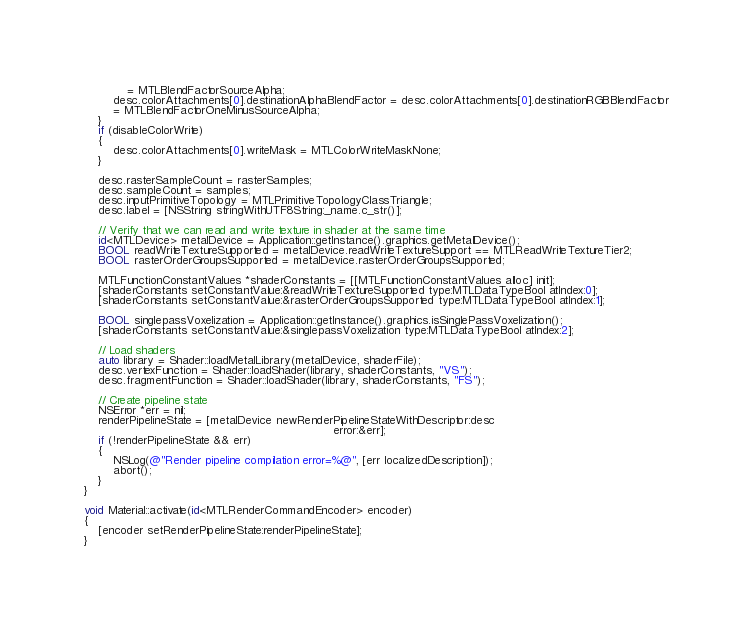Convert code to text. <code><loc_0><loc_0><loc_500><loc_500><_ObjectiveC_>			= MTLBlendFactorSourceAlpha;
		desc.colorAttachments[0].destinationAlphaBlendFactor = desc.colorAttachments[0].destinationRGBBlendFactor
		= MTLBlendFactorOneMinusSourceAlpha;
	}
	if (disableColorWrite)
	{
		desc.colorAttachments[0].writeMask = MTLColorWriteMaskNone;
	}

	desc.rasterSampleCount = rasterSamples;
	desc.sampleCount = samples;
	desc.inputPrimitiveTopology = MTLPrimitiveTopologyClassTriangle;
	desc.label = [NSString stringWithUTF8String:_name.c_str()];

	// Verify that we can read and write texture in shader at the same time
	id<MTLDevice> metalDevice = Application::getInstance().graphics.getMetalDevice();
	BOOL readWriteTextureSupported = metalDevice.readWriteTextureSupport == MTLReadWriteTextureTier2;
	BOOL rasterOrderGroupsSupported = metalDevice.rasterOrderGroupsSupported;

	MTLFunctionConstantValues *shaderConstants = [[MTLFunctionConstantValues alloc] init];
	[shaderConstants setConstantValue:&readWriteTextureSupported type:MTLDataTypeBool atIndex:0];
	[shaderConstants setConstantValue:&rasterOrderGroupsSupported type:MTLDataTypeBool atIndex:1];

	BOOL singlepassVoxelization = Application::getInstance().graphics.isSinglePassVoxelization();
	[shaderConstants setConstantValue:&singlepassVoxelization type:MTLDataTypeBool atIndex:2];

	// Load shaders
	auto library = Shader::loadMetalLibrary(metalDevice, shaderFile);
	desc.vertexFunction = Shader::loadShader(library, shaderConstants, "VS");
	desc.fragmentFunction = Shader::loadShader(library, shaderConstants, "FS");

	// Create pipeline state
	NSError *err = nil;
	renderPipelineState = [metalDevice newRenderPipelineStateWithDescriptor:desc
																	  error:&err];
	if (!renderPipelineState && err)
	{
		NSLog(@"Render pipeline compilation error=%@", [err localizedDescription]);
		abort();
	}
}

void Material::activate(id<MTLRenderCommandEncoder> encoder)
{
	[encoder setRenderPipelineState:renderPipelineState];
}
</code> 